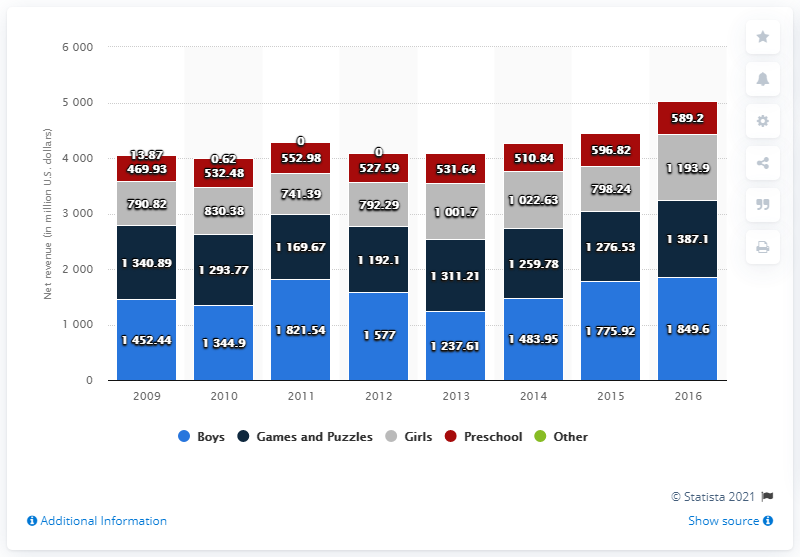Point out several critical features in this image. In 2010, the net revenue from games and puzzles was 1,293.77. 